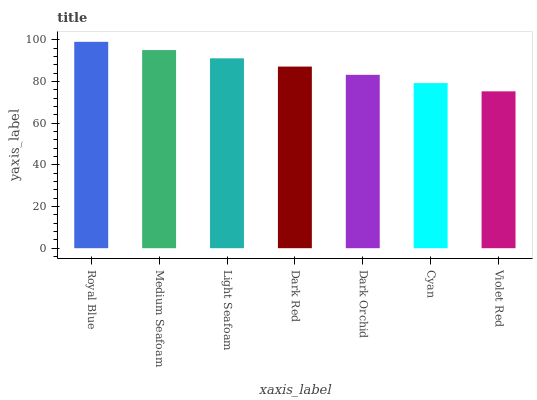Is Medium Seafoam the minimum?
Answer yes or no. No. Is Medium Seafoam the maximum?
Answer yes or no. No. Is Royal Blue greater than Medium Seafoam?
Answer yes or no. Yes. Is Medium Seafoam less than Royal Blue?
Answer yes or no. Yes. Is Medium Seafoam greater than Royal Blue?
Answer yes or no. No. Is Royal Blue less than Medium Seafoam?
Answer yes or no. No. Is Dark Red the high median?
Answer yes or no. Yes. Is Dark Red the low median?
Answer yes or no. Yes. Is Royal Blue the high median?
Answer yes or no. No. Is Royal Blue the low median?
Answer yes or no. No. 